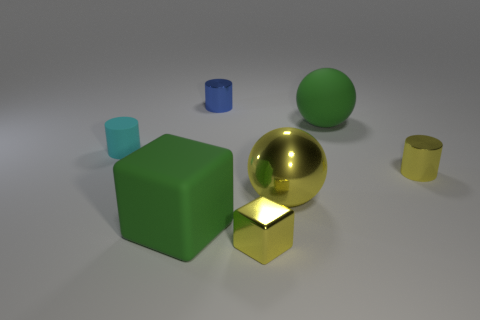Add 1 large yellow metallic spheres. How many objects exist? 8 Subtract all blocks. How many objects are left? 5 Add 7 large green blocks. How many large green blocks are left? 8 Add 5 large green matte balls. How many large green matte balls exist? 6 Subtract 1 yellow spheres. How many objects are left? 6 Subtract all big gray cubes. Subtract all small yellow metal objects. How many objects are left? 5 